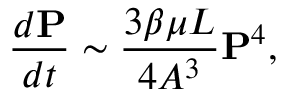Convert formula to latex. <formula><loc_0><loc_0><loc_500><loc_500>\frac { d P } { d t } \sim \frac { 3 \beta \mu L } { 4 A ^ { 3 } } P ^ { 4 } ,</formula> 